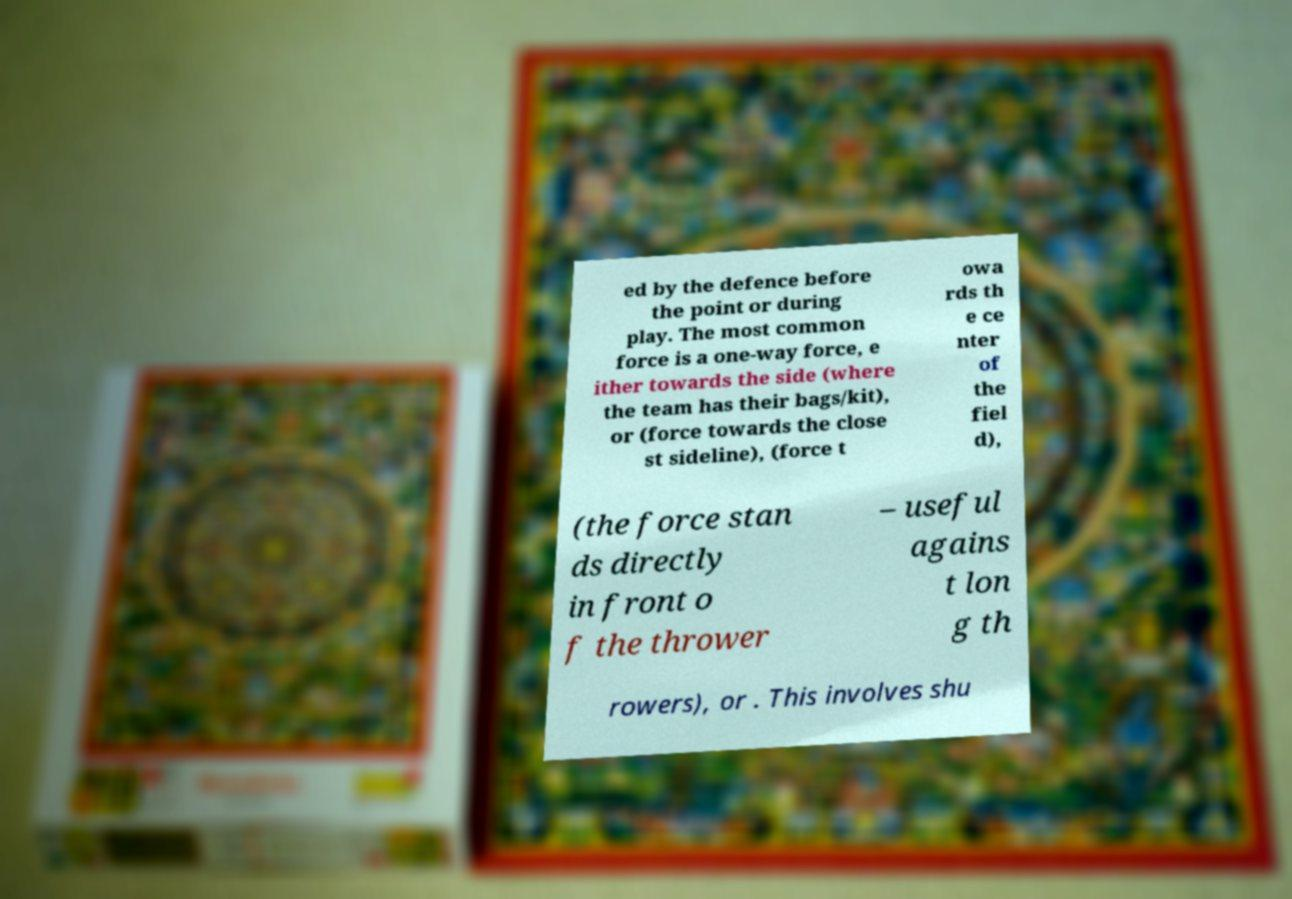For documentation purposes, I need the text within this image transcribed. Could you provide that? ed by the defence before the point or during play. The most common force is a one-way force, e ither towards the side (where the team has their bags/kit), or (force towards the close st sideline), (force t owa rds th e ce nter of the fiel d), (the force stan ds directly in front o f the thrower – useful agains t lon g th rowers), or . This involves shu 